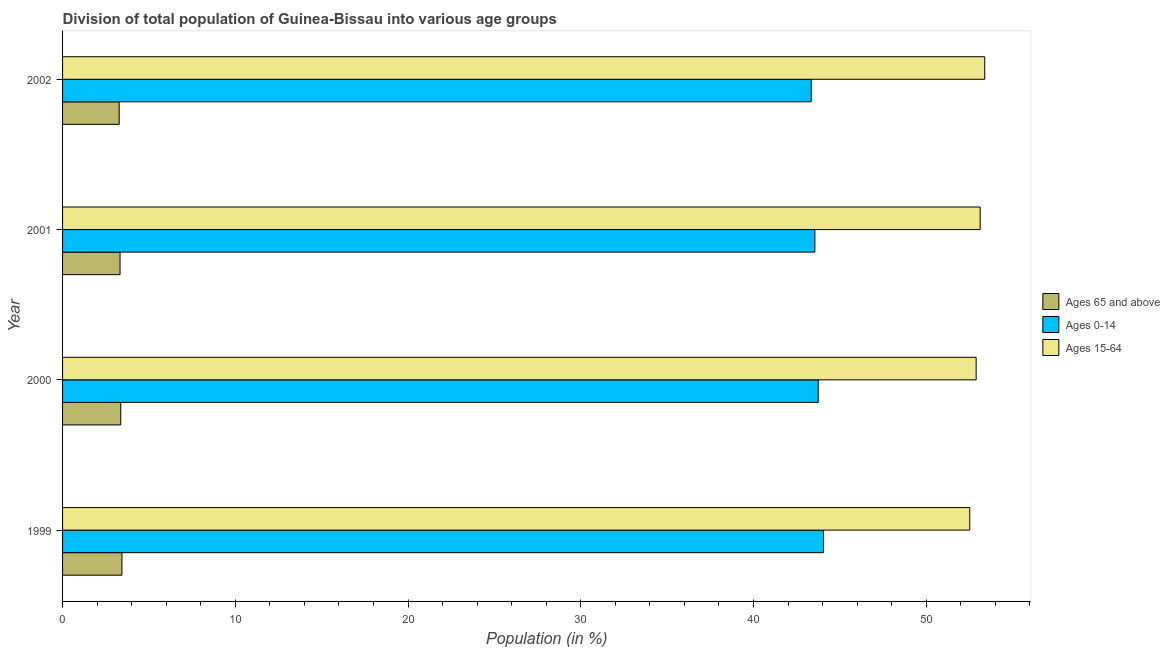How many different coloured bars are there?
Offer a very short reply. 3. How many groups of bars are there?
Provide a short and direct response. 4. What is the label of the 4th group of bars from the top?
Keep it short and to the point. 1999. In how many cases, is the number of bars for a given year not equal to the number of legend labels?
Make the answer very short. 0. What is the percentage of population within the age-group of 65 and above in 1999?
Your answer should be very brief. 3.44. Across all years, what is the maximum percentage of population within the age-group 15-64?
Your answer should be compact. 53.38. Across all years, what is the minimum percentage of population within the age-group 0-14?
Make the answer very short. 43.34. In which year was the percentage of population within the age-group 0-14 minimum?
Offer a terse response. 2002. What is the total percentage of population within the age-group 0-14 in the graph?
Your answer should be very brief. 174.68. What is the difference between the percentage of population within the age-group 15-64 in 1999 and that in 2001?
Make the answer very short. -0.6. What is the difference between the percentage of population within the age-group 15-64 in 2000 and the percentage of population within the age-group 0-14 in 2002?
Your response must be concise. 9.55. What is the average percentage of population within the age-group 0-14 per year?
Provide a short and direct response. 43.67. In the year 2000, what is the difference between the percentage of population within the age-group 15-64 and percentage of population within the age-group of 65 and above?
Provide a short and direct response. 49.52. What is the ratio of the percentage of population within the age-group of 65 and above in 2000 to that in 2001?
Your answer should be compact. 1.01. What is the difference between the highest and the second highest percentage of population within the age-group 15-64?
Ensure brevity in your answer.  0.26. What is the difference between the highest and the lowest percentage of population within the age-group 0-14?
Give a very brief answer. 0.71. In how many years, is the percentage of population within the age-group 0-14 greater than the average percentage of population within the age-group 0-14 taken over all years?
Make the answer very short. 2. Is the sum of the percentage of population within the age-group 0-14 in 1999 and 2001 greater than the maximum percentage of population within the age-group 15-64 across all years?
Offer a terse response. Yes. What does the 2nd bar from the top in 2000 represents?
Ensure brevity in your answer.  Ages 0-14. What does the 2nd bar from the bottom in 1999 represents?
Offer a very short reply. Ages 0-14. Is it the case that in every year, the sum of the percentage of population within the age-group of 65 and above and percentage of population within the age-group 0-14 is greater than the percentage of population within the age-group 15-64?
Offer a very short reply. No. How many bars are there?
Offer a very short reply. 12. How many years are there in the graph?
Make the answer very short. 4. What is the difference between two consecutive major ticks on the X-axis?
Provide a short and direct response. 10. Does the graph contain grids?
Keep it short and to the point. No. What is the title of the graph?
Keep it short and to the point. Division of total population of Guinea-Bissau into various age groups
. Does "Natural gas sources" appear as one of the legend labels in the graph?
Keep it short and to the point. No. What is the label or title of the Y-axis?
Your answer should be compact. Year. What is the Population (in %) of Ages 65 and above in 1999?
Provide a succinct answer. 3.44. What is the Population (in %) of Ages 0-14 in 1999?
Provide a succinct answer. 44.05. What is the Population (in %) of Ages 15-64 in 1999?
Make the answer very short. 52.52. What is the Population (in %) of Ages 65 and above in 2000?
Make the answer very short. 3.37. What is the Population (in %) in Ages 0-14 in 2000?
Ensure brevity in your answer.  43.74. What is the Population (in %) in Ages 15-64 in 2000?
Make the answer very short. 52.89. What is the Population (in %) in Ages 65 and above in 2001?
Make the answer very short. 3.33. What is the Population (in %) of Ages 0-14 in 2001?
Keep it short and to the point. 43.55. What is the Population (in %) in Ages 15-64 in 2001?
Offer a very short reply. 53.12. What is the Population (in %) of Ages 65 and above in 2002?
Make the answer very short. 3.28. What is the Population (in %) of Ages 0-14 in 2002?
Your response must be concise. 43.34. What is the Population (in %) in Ages 15-64 in 2002?
Your response must be concise. 53.38. Across all years, what is the maximum Population (in %) of Ages 65 and above?
Offer a terse response. 3.44. Across all years, what is the maximum Population (in %) in Ages 0-14?
Ensure brevity in your answer.  44.05. Across all years, what is the maximum Population (in %) in Ages 15-64?
Your answer should be very brief. 53.38. Across all years, what is the minimum Population (in %) in Ages 65 and above?
Make the answer very short. 3.28. Across all years, what is the minimum Population (in %) of Ages 0-14?
Provide a succinct answer. 43.34. Across all years, what is the minimum Population (in %) in Ages 15-64?
Provide a succinct answer. 52.52. What is the total Population (in %) in Ages 65 and above in the graph?
Ensure brevity in your answer.  13.41. What is the total Population (in %) of Ages 0-14 in the graph?
Make the answer very short. 174.68. What is the total Population (in %) in Ages 15-64 in the graph?
Provide a succinct answer. 211.91. What is the difference between the Population (in %) of Ages 65 and above in 1999 and that in 2000?
Your response must be concise. 0.07. What is the difference between the Population (in %) of Ages 0-14 in 1999 and that in 2000?
Your answer should be very brief. 0.3. What is the difference between the Population (in %) of Ages 15-64 in 1999 and that in 2000?
Make the answer very short. -0.37. What is the difference between the Population (in %) of Ages 65 and above in 1999 and that in 2001?
Provide a short and direct response. 0.11. What is the difference between the Population (in %) of Ages 0-14 in 1999 and that in 2001?
Keep it short and to the point. 0.49. What is the difference between the Population (in %) of Ages 15-64 in 1999 and that in 2001?
Keep it short and to the point. -0.6. What is the difference between the Population (in %) of Ages 65 and above in 1999 and that in 2002?
Offer a very short reply. 0.16. What is the difference between the Population (in %) in Ages 0-14 in 1999 and that in 2002?
Offer a very short reply. 0.71. What is the difference between the Population (in %) in Ages 15-64 in 1999 and that in 2002?
Provide a succinct answer. -0.87. What is the difference between the Population (in %) of Ages 65 and above in 2000 and that in 2001?
Your answer should be compact. 0.04. What is the difference between the Population (in %) of Ages 0-14 in 2000 and that in 2001?
Your answer should be very brief. 0.19. What is the difference between the Population (in %) of Ages 15-64 in 2000 and that in 2001?
Your answer should be very brief. -0.23. What is the difference between the Population (in %) of Ages 65 and above in 2000 and that in 2002?
Your answer should be compact. 0.09. What is the difference between the Population (in %) in Ages 0-14 in 2000 and that in 2002?
Keep it short and to the point. 0.41. What is the difference between the Population (in %) of Ages 15-64 in 2000 and that in 2002?
Keep it short and to the point. -0.5. What is the difference between the Population (in %) in Ages 65 and above in 2001 and that in 2002?
Provide a succinct answer. 0.05. What is the difference between the Population (in %) in Ages 0-14 in 2001 and that in 2002?
Provide a succinct answer. 0.21. What is the difference between the Population (in %) in Ages 15-64 in 2001 and that in 2002?
Provide a short and direct response. -0.26. What is the difference between the Population (in %) in Ages 65 and above in 1999 and the Population (in %) in Ages 0-14 in 2000?
Provide a short and direct response. -40.31. What is the difference between the Population (in %) in Ages 65 and above in 1999 and the Population (in %) in Ages 15-64 in 2000?
Give a very brief answer. -49.45. What is the difference between the Population (in %) in Ages 0-14 in 1999 and the Population (in %) in Ages 15-64 in 2000?
Your answer should be very brief. -8.84. What is the difference between the Population (in %) of Ages 65 and above in 1999 and the Population (in %) of Ages 0-14 in 2001?
Your answer should be very brief. -40.11. What is the difference between the Population (in %) in Ages 65 and above in 1999 and the Population (in %) in Ages 15-64 in 2001?
Offer a very short reply. -49.68. What is the difference between the Population (in %) of Ages 0-14 in 1999 and the Population (in %) of Ages 15-64 in 2001?
Provide a succinct answer. -9.07. What is the difference between the Population (in %) in Ages 65 and above in 1999 and the Population (in %) in Ages 0-14 in 2002?
Your response must be concise. -39.9. What is the difference between the Population (in %) of Ages 65 and above in 1999 and the Population (in %) of Ages 15-64 in 2002?
Your response must be concise. -49.95. What is the difference between the Population (in %) in Ages 0-14 in 1999 and the Population (in %) in Ages 15-64 in 2002?
Your response must be concise. -9.34. What is the difference between the Population (in %) of Ages 65 and above in 2000 and the Population (in %) of Ages 0-14 in 2001?
Keep it short and to the point. -40.18. What is the difference between the Population (in %) of Ages 65 and above in 2000 and the Population (in %) of Ages 15-64 in 2001?
Provide a succinct answer. -49.75. What is the difference between the Population (in %) in Ages 0-14 in 2000 and the Population (in %) in Ages 15-64 in 2001?
Your answer should be very brief. -9.38. What is the difference between the Population (in %) of Ages 65 and above in 2000 and the Population (in %) of Ages 0-14 in 2002?
Provide a succinct answer. -39.97. What is the difference between the Population (in %) in Ages 65 and above in 2000 and the Population (in %) in Ages 15-64 in 2002?
Make the answer very short. -50.02. What is the difference between the Population (in %) of Ages 0-14 in 2000 and the Population (in %) of Ages 15-64 in 2002?
Provide a short and direct response. -9.64. What is the difference between the Population (in %) in Ages 65 and above in 2001 and the Population (in %) in Ages 0-14 in 2002?
Your response must be concise. -40.01. What is the difference between the Population (in %) of Ages 65 and above in 2001 and the Population (in %) of Ages 15-64 in 2002?
Offer a very short reply. -50.06. What is the difference between the Population (in %) of Ages 0-14 in 2001 and the Population (in %) of Ages 15-64 in 2002?
Provide a short and direct response. -9.83. What is the average Population (in %) in Ages 65 and above per year?
Make the answer very short. 3.35. What is the average Population (in %) in Ages 0-14 per year?
Make the answer very short. 43.67. What is the average Population (in %) in Ages 15-64 per year?
Give a very brief answer. 52.98. In the year 1999, what is the difference between the Population (in %) in Ages 65 and above and Population (in %) in Ages 0-14?
Offer a very short reply. -40.61. In the year 1999, what is the difference between the Population (in %) in Ages 65 and above and Population (in %) in Ages 15-64?
Offer a terse response. -49.08. In the year 1999, what is the difference between the Population (in %) of Ages 0-14 and Population (in %) of Ages 15-64?
Offer a very short reply. -8.47. In the year 2000, what is the difference between the Population (in %) of Ages 65 and above and Population (in %) of Ages 0-14?
Make the answer very short. -40.38. In the year 2000, what is the difference between the Population (in %) in Ages 65 and above and Population (in %) in Ages 15-64?
Your answer should be very brief. -49.52. In the year 2000, what is the difference between the Population (in %) in Ages 0-14 and Population (in %) in Ages 15-64?
Provide a succinct answer. -9.14. In the year 2001, what is the difference between the Population (in %) of Ages 65 and above and Population (in %) of Ages 0-14?
Offer a terse response. -40.22. In the year 2001, what is the difference between the Population (in %) of Ages 65 and above and Population (in %) of Ages 15-64?
Make the answer very short. -49.79. In the year 2001, what is the difference between the Population (in %) in Ages 0-14 and Population (in %) in Ages 15-64?
Provide a short and direct response. -9.57. In the year 2002, what is the difference between the Population (in %) of Ages 65 and above and Population (in %) of Ages 0-14?
Make the answer very short. -40.06. In the year 2002, what is the difference between the Population (in %) in Ages 65 and above and Population (in %) in Ages 15-64?
Offer a very short reply. -50.11. In the year 2002, what is the difference between the Population (in %) in Ages 0-14 and Population (in %) in Ages 15-64?
Your response must be concise. -10.05. What is the ratio of the Population (in %) in Ages 65 and above in 1999 to that in 2000?
Provide a succinct answer. 1.02. What is the ratio of the Population (in %) of Ages 15-64 in 1999 to that in 2000?
Your answer should be compact. 0.99. What is the ratio of the Population (in %) in Ages 65 and above in 1999 to that in 2001?
Provide a short and direct response. 1.03. What is the ratio of the Population (in %) in Ages 0-14 in 1999 to that in 2001?
Provide a short and direct response. 1.01. What is the ratio of the Population (in %) in Ages 65 and above in 1999 to that in 2002?
Provide a short and direct response. 1.05. What is the ratio of the Population (in %) in Ages 0-14 in 1999 to that in 2002?
Offer a very short reply. 1.02. What is the ratio of the Population (in %) of Ages 15-64 in 1999 to that in 2002?
Your response must be concise. 0.98. What is the ratio of the Population (in %) of Ages 65 and above in 2000 to that in 2001?
Your answer should be compact. 1.01. What is the ratio of the Population (in %) of Ages 0-14 in 2000 to that in 2001?
Keep it short and to the point. 1. What is the ratio of the Population (in %) in Ages 15-64 in 2000 to that in 2001?
Make the answer very short. 1. What is the ratio of the Population (in %) in Ages 65 and above in 2000 to that in 2002?
Provide a succinct answer. 1.03. What is the ratio of the Population (in %) in Ages 0-14 in 2000 to that in 2002?
Provide a succinct answer. 1.01. What is the ratio of the Population (in %) in Ages 65 and above in 2001 to that in 2002?
Offer a very short reply. 1.02. What is the difference between the highest and the second highest Population (in %) in Ages 65 and above?
Offer a terse response. 0.07. What is the difference between the highest and the second highest Population (in %) in Ages 0-14?
Offer a very short reply. 0.3. What is the difference between the highest and the second highest Population (in %) in Ages 15-64?
Provide a short and direct response. 0.26. What is the difference between the highest and the lowest Population (in %) of Ages 65 and above?
Offer a terse response. 0.16. What is the difference between the highest and the lowest Population (in %) of Ages 0-14?
Offer a very short reply. 0.71. What is the difference between the highest and the lowest Population (in %) in Ages 15-64?
Provide a succinct answer. 0.87. 